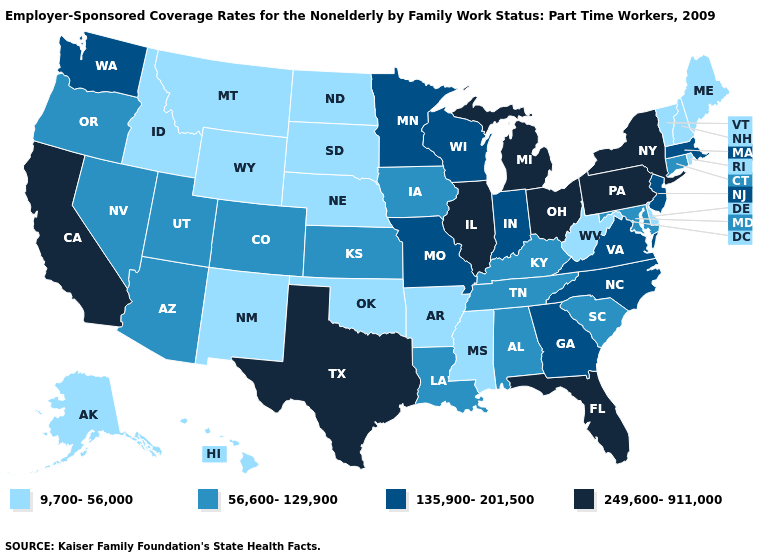Which states have the lowest value in the MidWest?
Be succinct. Nebraska, North Dakota, South Dakota. Does Texas have the lowest value in the South?
Concise answer only. No. What is the lowest value in the USA?
Concise answer only. 9,700-56,000. What is the value of New Hampshire?
Quick response, please. 9,700-56,000. What is the value of Connecticut?
Answer briefly. 56,600-129,900. Name the states that have a value in the range 249,600-911,000?
Quick response, please. California, Florida, Illinois, Michigan, New York, Ohio, Pennsylvania, Texas. What is the value of Nebraska?
Concise answer only. 9,700-56,000. What is the highest value in states that border Florida?
Answer briefly. 135,900-201,500. Is the legend a continuous bar?
Quick response, please. No. Which states have the lowest value in the Northeast?
Keep it brief. Maine, New Hampshire, Rhode Island, Vermont. Does Kansas have the same value as New York?
Be succinct. No. What is the value of Arizona?
Concise answer only. 56,600-129,900. What is the value of Wyoming?
Short answer required. 9,700-56,000. Name the states that have a value in the range 56,600-129,900?
Quick response, please. Alabama, Arizona, Colorado, Connecticut, Iowa, Kansas, Kentucky, Louisiana, Maryland, Nevada, Oregon, South Carolina, Tennessee, Utah. Does Oregon have the lowest value in the West?
Concise answer only. No. 